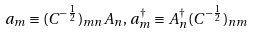Convert formula to latex. <formula><loc_0><loc_0><loc_500><loc_500>a _ { m } \equiv ( C ^ { - \frac { 1 } { 2 } } ) _ { m n } A _ { n } , \, a ^ { \dagger } _ { m } \equiv A ^ { \dagger } _ { n } ( C ^ { - \frac { 1 } { 2 } } ) _ { n m }</formula> 